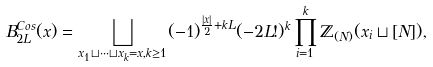Convert formula to latex. <formula><loc_0><loc_0><loc_500><loc_500>B _ { 2 L } ^ { C o s } ( x ) = \bigsqcup _ { x _ { 1 } \sqcup \dots \sqcup x _ { k } = x , k \geq 1 } ( - 1 ) ^ { \frac { | x | } { 2 } + k L } ( - 2 L ! ) ^ { k } \prod _ { i = 1 } ^ { k } \mathbb { Z } _ { ( N ) } ( x _ { i } \sqcup [ N ] ) ,</formula> 